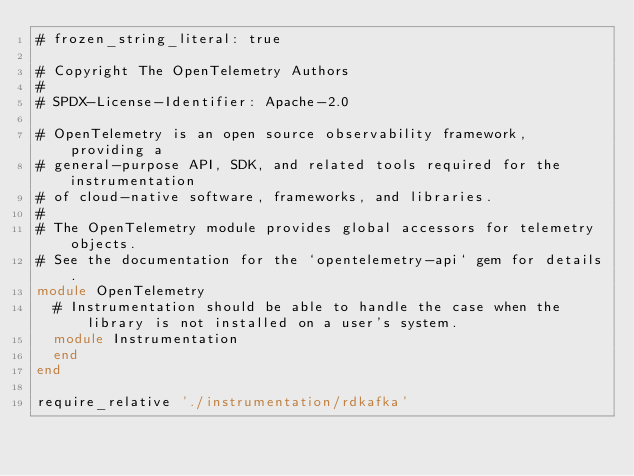<code> <loc_0><loc_0><loc_500><loc_500><_Ruby_># frozen_string_literal: true

# Copyright The OpenTelemetry Authors
#
# SPDX-License-Identifier: Apache-2.0

# OpenTelemetry is an open source observability framework, providing a
# general-purpose API, SDK, and related tools required for the instrumentation
# of cloud-native software, frameworks, and libraries.
#
# The OpenTelemetry module provides global accessors for telemetry objects.
# See the documentation for the `opentelemetry-api` gem for details.
module OpenTelemetry
  # Instrumentation should be able to handle the case when the library is not installed on a user's system.
  module Instrumentation
  end
end

require_relative './instrumentation/rdkafka'
</code> 